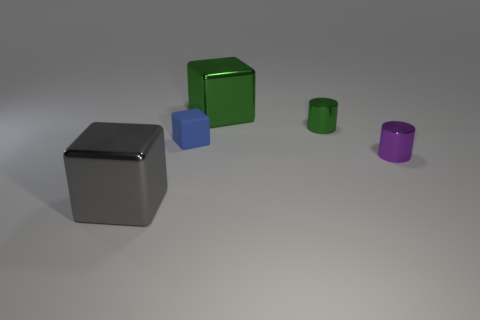What is the color of the other metal block that is the same size as the gray shiny cube?
Provide a short and direct response. Green. How many objects are either small purple metal objects or yellow objects?
Offer a very short reply. 1. There is a metal block that is in front of the big object that is to the right of the big object that is on the left side of the blue rubber thing; what size is it?
Your answer should be very brief. Large. What number of other large gray objects have the same material as the gray thing?
Your response must be concise. 0. What number of things are blue cylinders or objects that are in front of the small green object?
Your answer should be compact. 3. There is a object in front of the tiny shiny thing that is to the right of the small metallic cylinder behind the blue object; what color is it?
Ensure brevity in your answer.  Gray. What is the size of the metal cube behind the green metallic cylinder?
Offer a terse response. Large. What number of big objects are either rubber objects or purple metallic objects?
Make the answer very short. 0. What color is the metallic thing that is on the left side of the green cylinder and behind the tiny purple object?
Your answer should be very brief. Green. Is there a tiny purple shiny object that has the same shape as the blue rubber object?
Keep it short and to the point. No. 